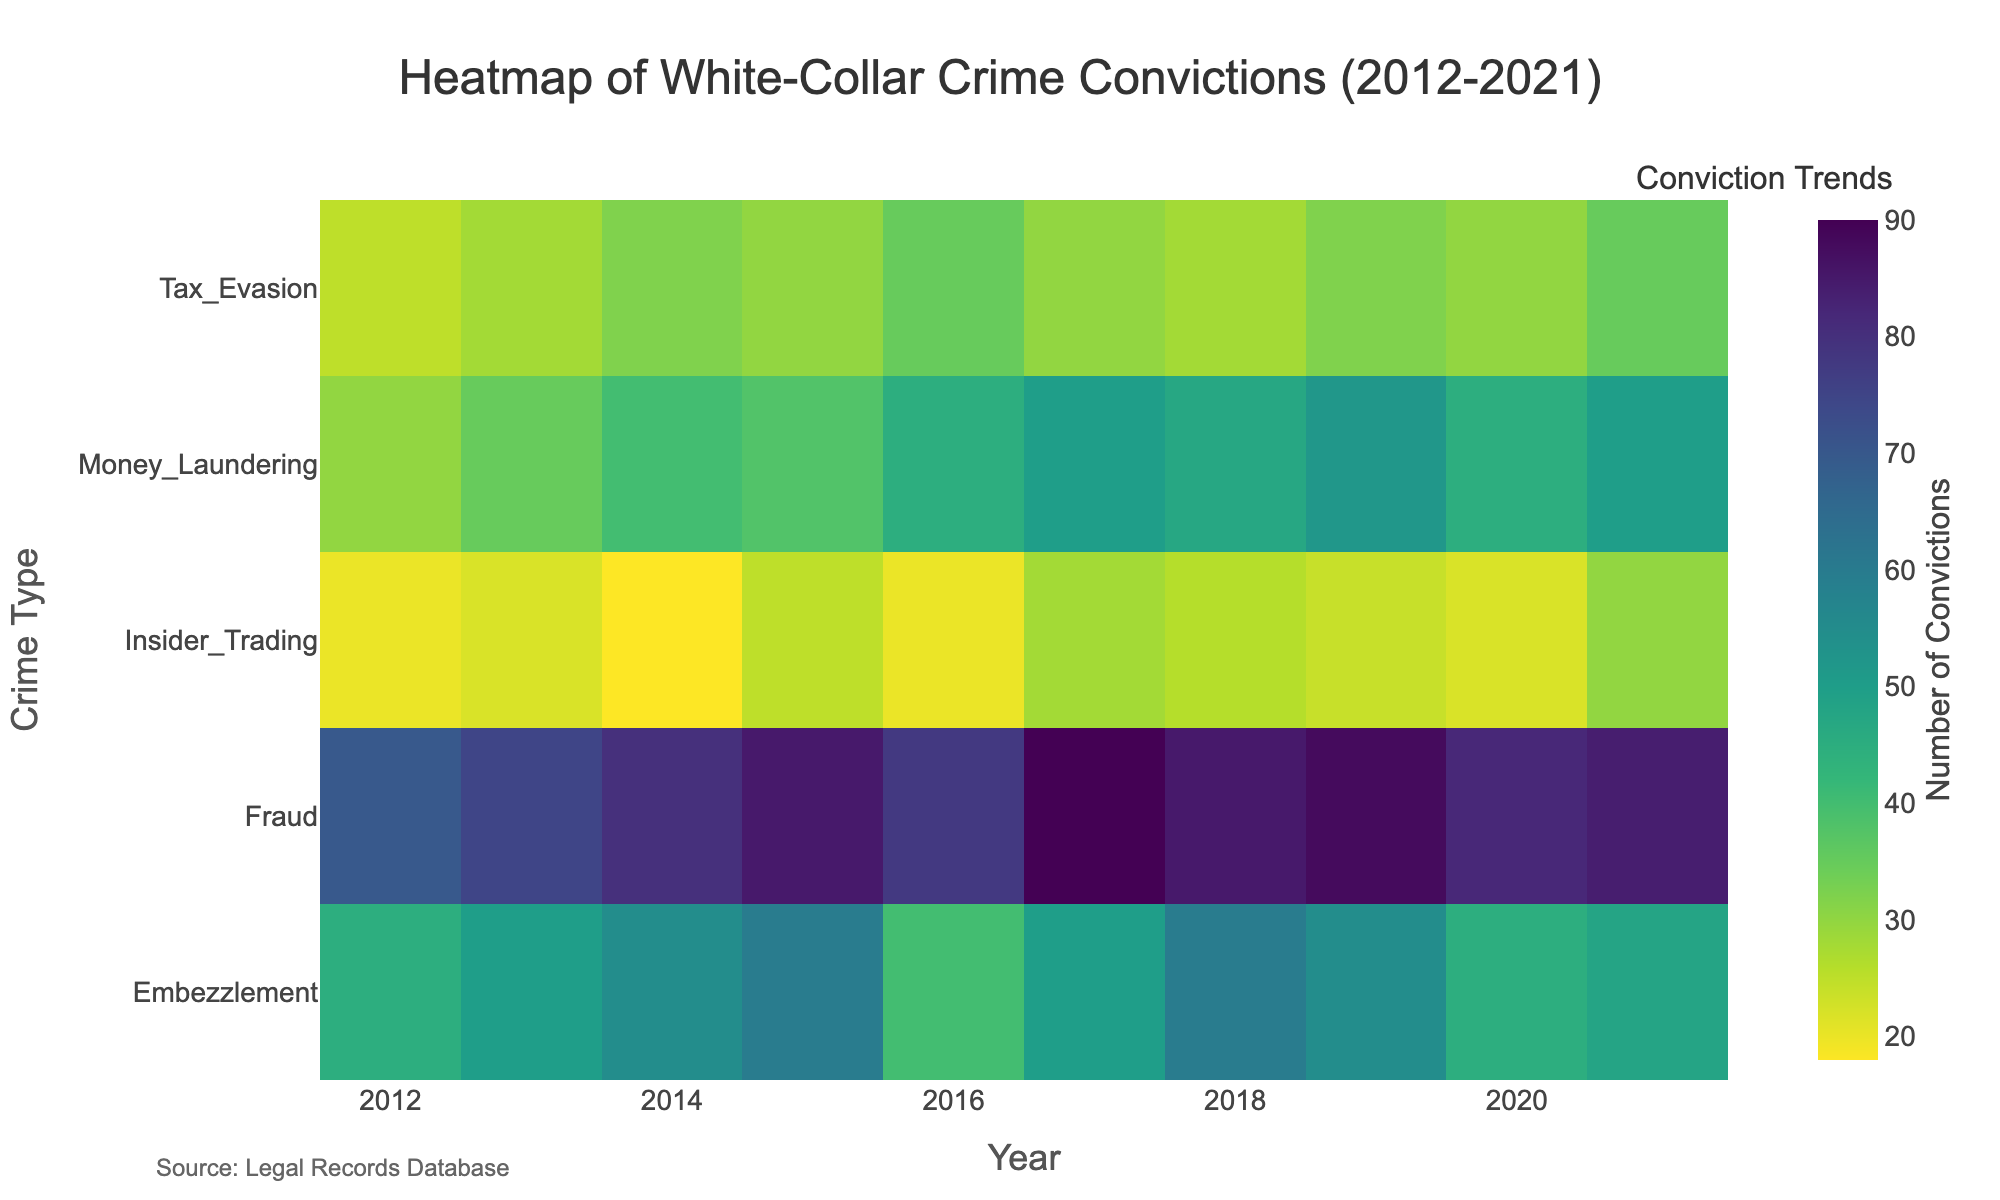What is the title of the heatmap? The title of the heatmap is written at the top and is comprehensive and descriptive of the visualized data.
Answer: Heatmap of White-Collar Crime Convictions (2012-2021) What is the color scale used in the heatmap? The color scale used in the heatmap is indicated by the color gradient from light to dark. This information is often confirmed by the color legend.
Answer: Viridis Which year had the highest number of embezzlement convictions? Look at the row corresponding to Embezzlement and identify the year with the darkest-colored cell, representing the highest number of convictions.
Answer: 2015 Which crime type consistently had the highest number of convictions? Compare the colors across all crime types for each year, paying attention to the overall darkest sections.
Answer: Fraud What was the trend in money laundering convictions from 2012 to 2021? Observe the gradient changes in the row corresponding to Money Laundering over the years, identifying any increases or decreases in the color intensity.
Answer: Increasing trend with minor fluctuations How do the convictions of insider trading in 2021 compare to those in 2012? Compare the color intensity of the cell for insider trading in 2021 with that of 2012. A darker color means a higher number of convictions.
Answer: Higher in 2021 Which years had the highest number of tax evasion convictions? Look at the row for Tax Evasion and identify the years with the darkest cells, representing the highest number of convictions.
Answer: 2016 and 2021 Is there a noticeable difference in the conviction trends of fraud and embezzlement over the years? Compare the gradients of colors in the rows corresponding to Fraud and Embezzlement from 2012 to 2021 to identify differing trends.
Answer: Fraud shows a consistently high number of convictions, whereas Embezzlement fluctuates What was the most common outcome for insider trading cases in 2015? Although the heatmap primarily shows convictions, examine the intensity of the cells. For detailed outcomes, refer to the data table provided.
Answer: Convicted 